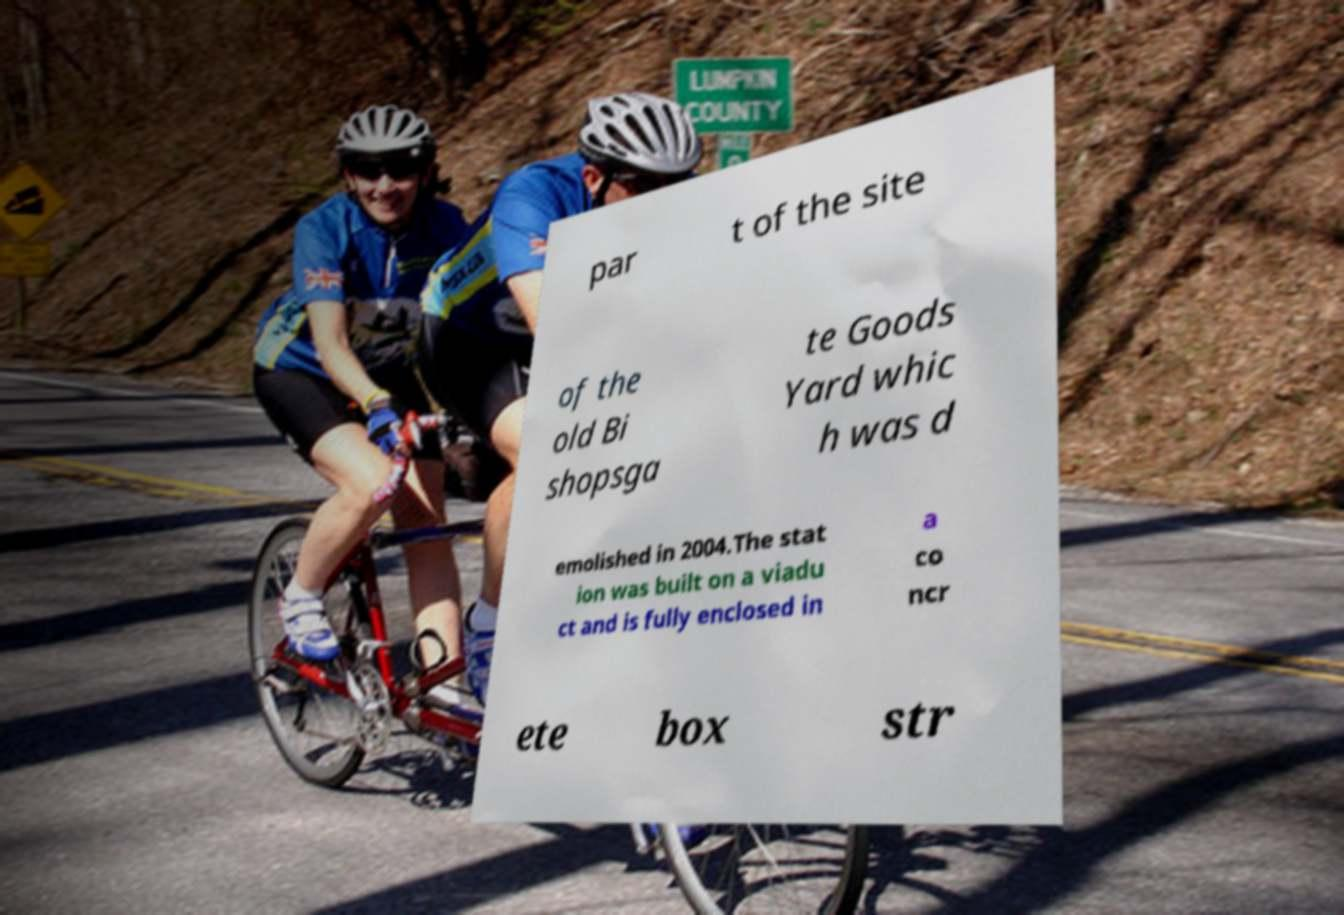Can you read and provide the text displayed in the image?This photo seems to have some interesting text. Can you extract and type it out for me? par t of the site of the old Bi shopsga te Goods Yard whic h was d emolished in 2004.The stat ion was built on a viadu ct and is fully enclosed in a co ncr ete box str 